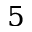Convert formula to latex. <formula><loc_0><loc_0><loc_500><loc_500>5</formula> 